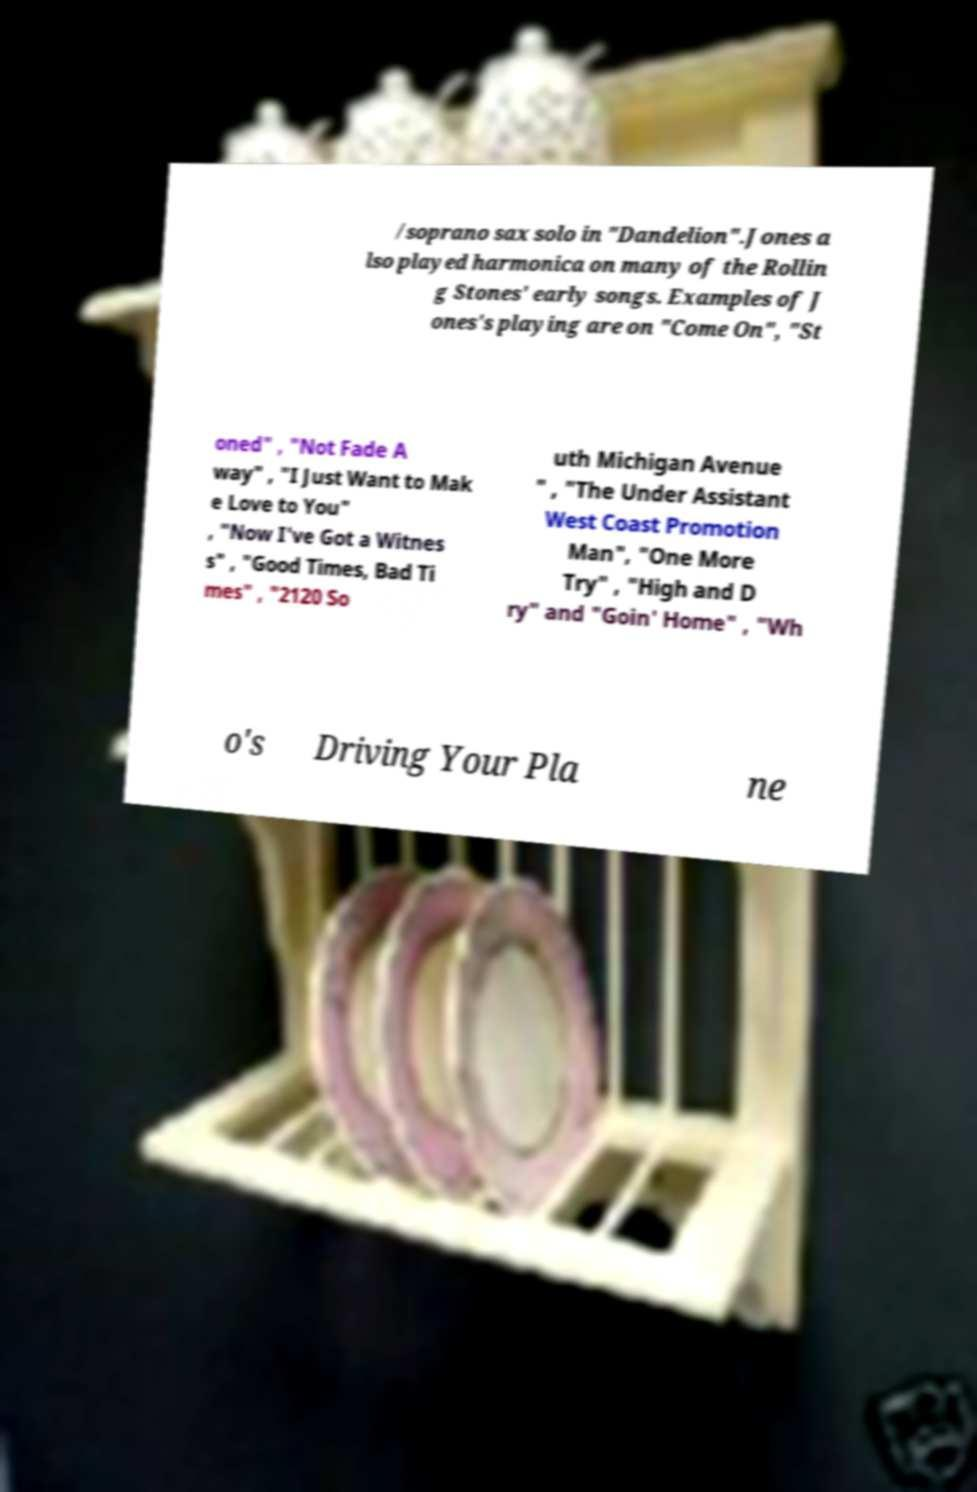Please read and relay the text visible in this image. What does it say? /soprano sax solo in "Dandelion".Jones a lso played harmonica on many of the Rollin g Stones' early songs. Examples of J ones's playing are on "Come On", "St oned" , "Not Fade A way" , "I Just Want to Mak e Love to You" , "Now I've Got a Witnes s" , "Good Times, Bad Ti mes" , "2120 So uth Michigan Avenue " , "The Under Assistant West Coast Promotion Man", "One More Try" , "High and D ry" and "Goin' Home" , "Wh o's Driving Your Pla ne 